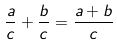<formula> <loc_0><loc_0><loc_500><loc_500>\frac { a } { c } + \frac { b } { c } = \frac { a + b } { c }</formula> 